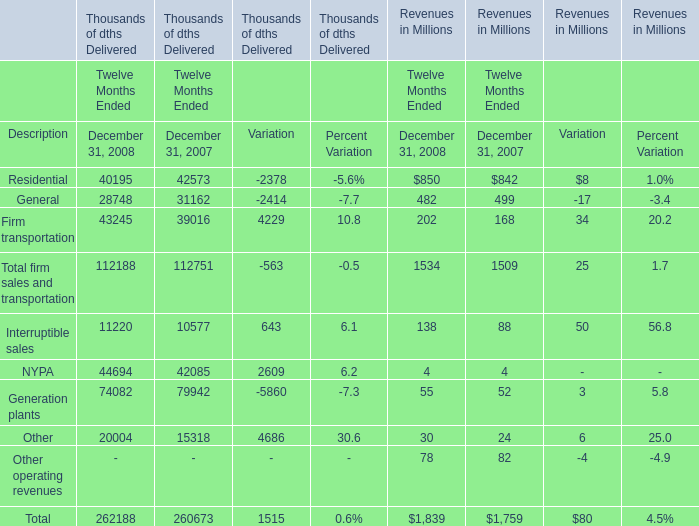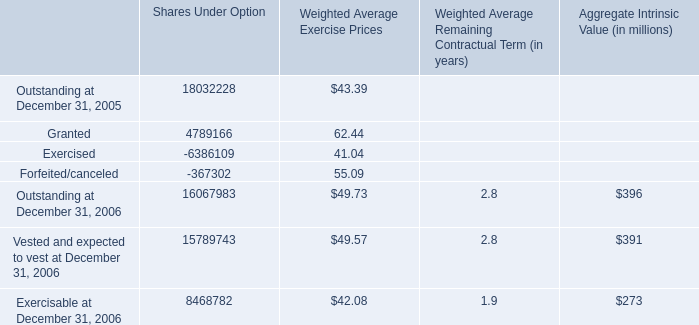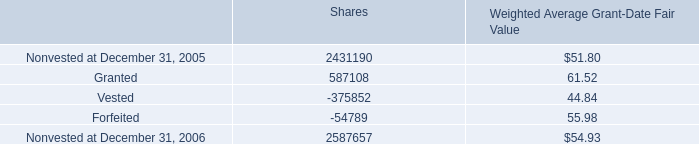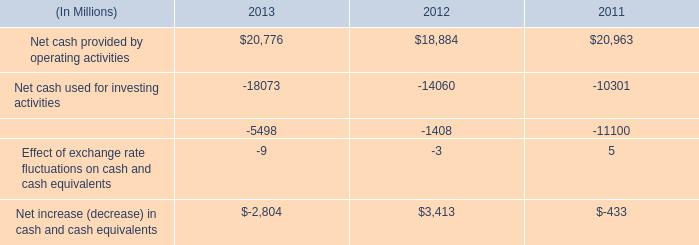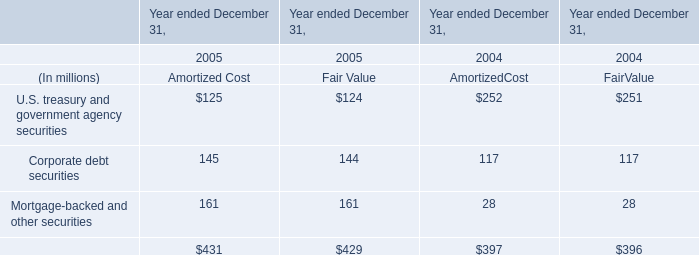What is the sum of Nonvested at December 31, 2006 of Shares, and NYPA of Thousands of dths Delivered Variation ? 
Computations: (2587657.0 + 2609.0)
Answer: 2590266.0. 